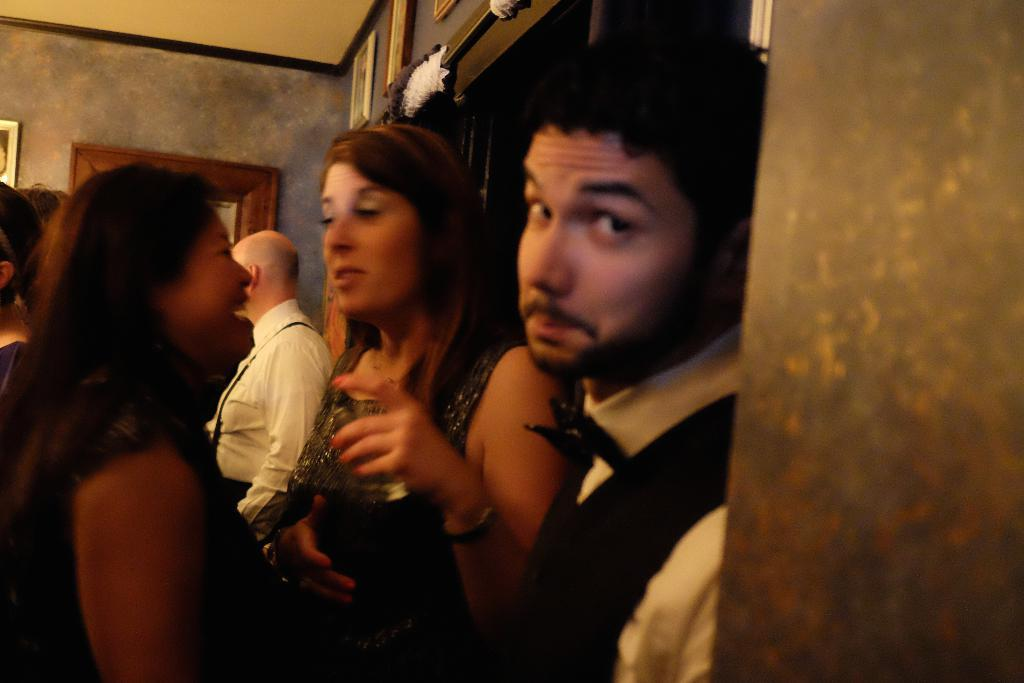What is happening in the image? There are people standing in the image. What can be seen in the background of the image? There is a wall with photo frames in the background of the image. How many ants are crawling on the people in the image? There are no ants present in the image; it only features people standing and a wall with photo frames in the background. 